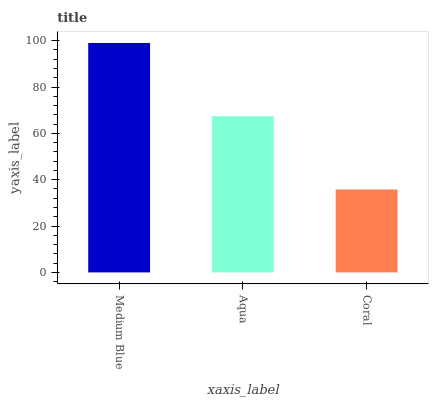Is Coral the minimum?
Answer yes or no. Yes. Is Medium Blue the maximum?
Answer yes or no. Yes. Is Aqua the minimum?
Answer yes or no. No. Is Aqua the maximum?
Answer yes or no. No. Is Medium Blue greater than Aqua?
Answer yes or no. Yes. Is Aqua less than Medium Blue?
Answer yes or no. Yes. Is Aqua greater than Medium Blue?
Answer yes or no. No. Is Medium Blue less than Aqua?
Answer yes or no. No. Is Aqua the high median?
Answer yes or no. Yes. Is Aqua the low median?
Answer yes or no. Yes. Is Medium Blue the high median?
Answer yes or no. No. Is Coral the low median?
Answer yes or no. No. 